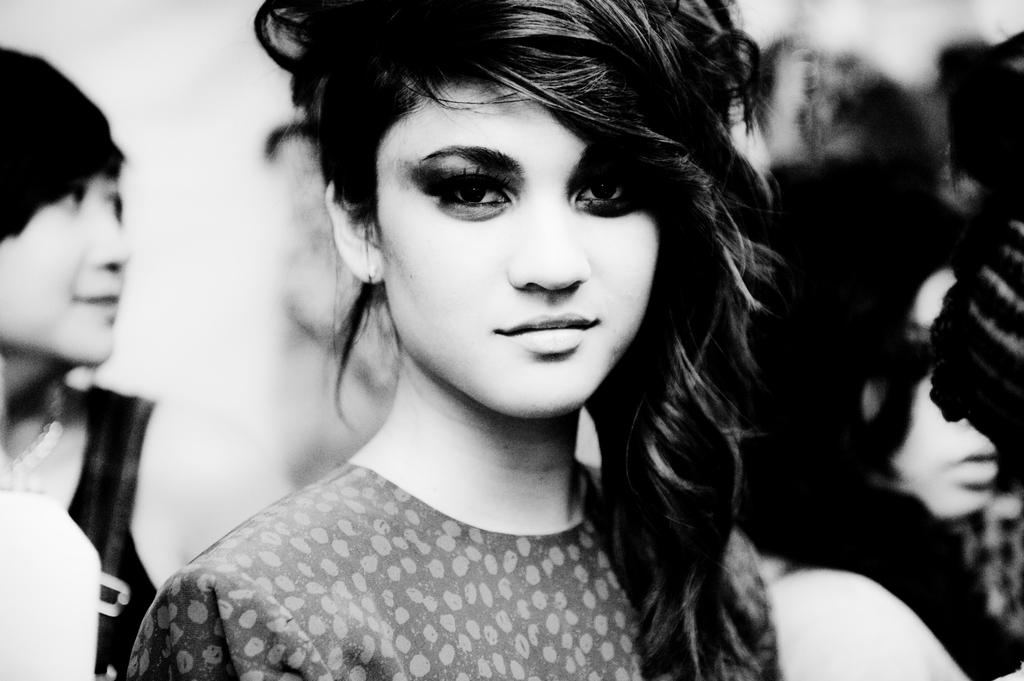What is the color scheme of the image? The image is black and white. What can be seen in the foreground of the image? There are people standing in the image. How would you describe the background of the image? The background of the image is blurry. Where is the mailbox located in the image? There is no mailbox present in the image. What type of field can be seen in the background of the image? There is no field visible in the image, as the background is blurry. How many potatoes are visible in the image? There are no potatoes present in the image. 